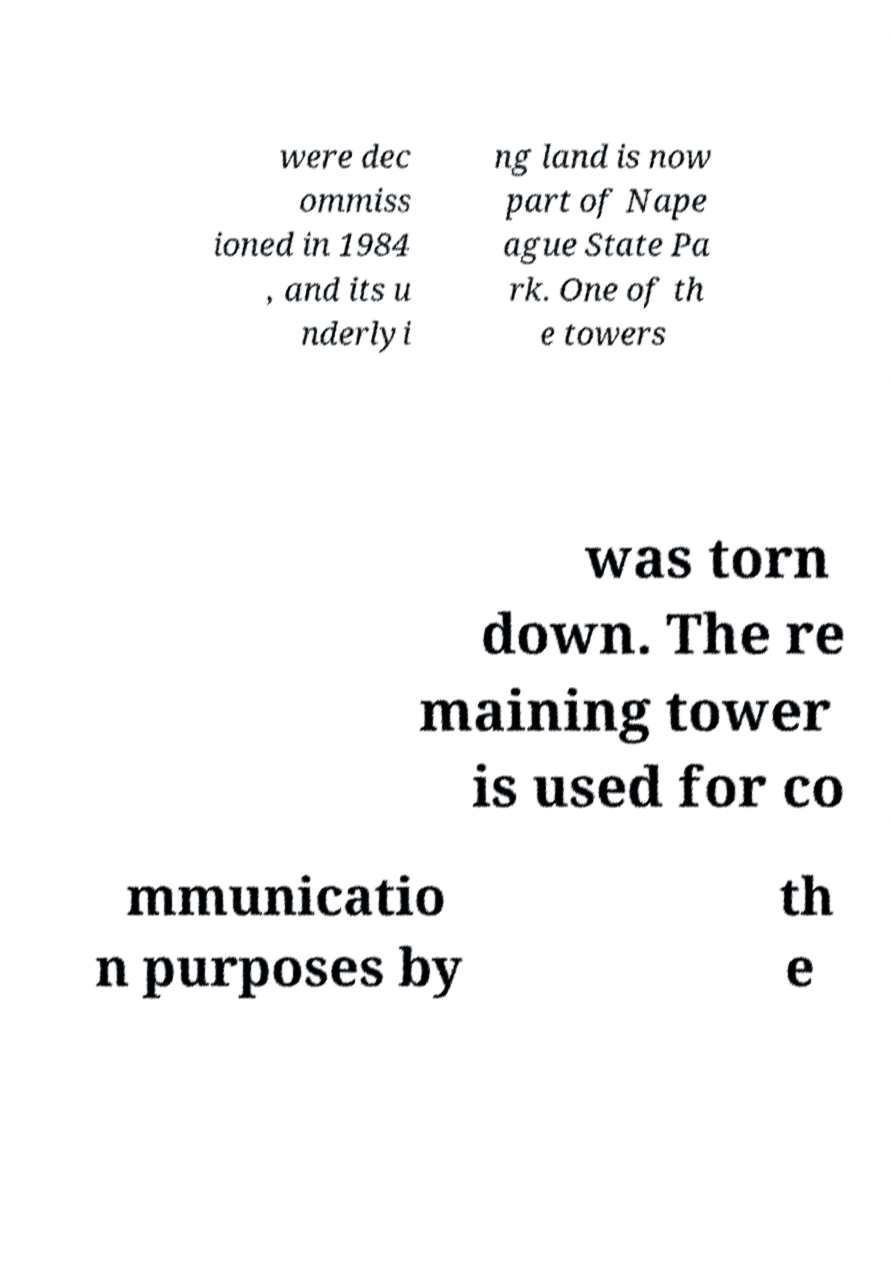Can you accurately transcribe the text from the provided image for me? were dec ommiss ioned in 1984 , and its u nderlyi ng land is now part of Nape ague State Pa rk. One of th e towers was torn down. The re maining tower is used for co mmunicatio n purposes by th e 